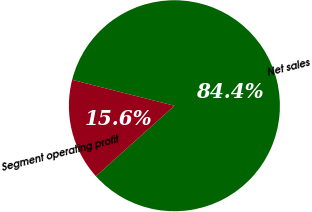<chart> <loc_0><loc_0><loc_500><loc_500><pie_chart><fcel>Net sales<fcel>Segment operating profit<nl><fcel>84.41%<fcel>15.59%<nl></chart> 